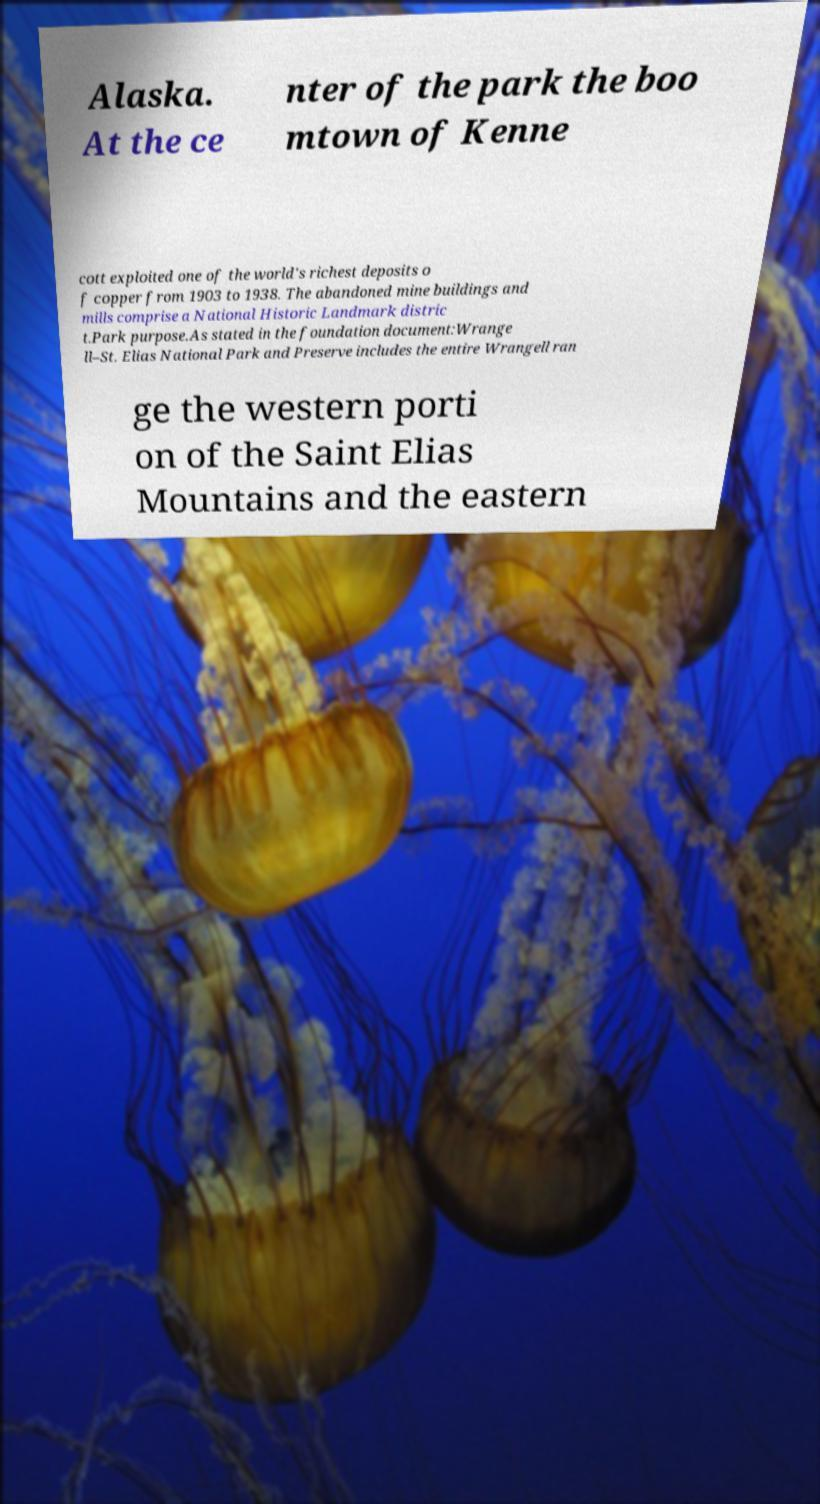Could you assist in decoding the text presented in this image and type it out clearly? Alaska. At the ce nter of the park the boo mtown of Kenne cott exploited one of the world's richest deposits o f copper from 1903 to 1938. The abandoned mine buildings and mills comprise a National Historic Landmark distric t.Park purpose.As stated in the foundation document:Wrange ll–St. Elias National Park and Preserve includes the entire Wrangell ran ge the western porti on of the Saint Elias Mountains and the eastern 